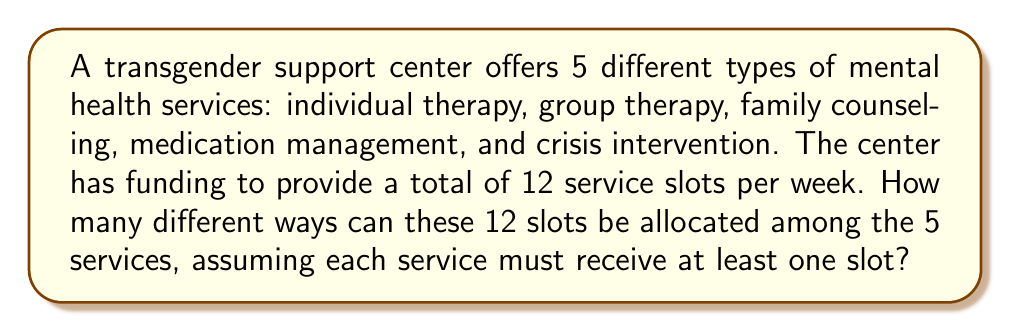Help me with this question. This problem can be solved using combinatorics, specifically the stars and bars method. Let's approach this step-by-step:

1) We need to distribute 12 slots among 5 services, with each service getting at least one slot. This is equivalent to distributing 7 remaining slots (12 - 5 = 7) among 5 services without restrictions.

2) In combinatorics, this scenario is represented as:
   $$\binom{n+k-1}{k-1}$$
   where n is the number of items to distribute (remaining slots) and k is the number of categories (services).

3) In our case, n = 7 and k = 5. So we need to calculate:
   $$\binom{7+5-1}{5-1} = \binom{11}{4}$$

4) This can be calculated as:
   $$\binom{11}{4} = \frac{11!}{4!(11-4)!} = \frac{11!}{4!7!}$$

5) Expanding this:
   $$\frac{11 \times 10 \times 9 \times 8 \times 7!}{(4 \times 3 \times 2 \times 1) \times 7!}$$

6) The 7! cancels out in the numerator and denominator:
   $$\frac{11 \times 10 \times 9 \times 8}{4 \times 3 \times 2 \times 1} = \frac{7920}{24} = 330$$

Therefore, there are 330 different ways to allocate the 12 service slots among the 5 mental health services, ensuring each service receives at least one slot.
Answer: 330 ways 